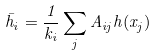<formula> <loc_0><loc_0><loc_500><loc_500>\bar { h } _ { i } = \frac { 1 } { k _ { i } } \sum _ { j } A _ { i j } h ( x _ { j } )</formula> 